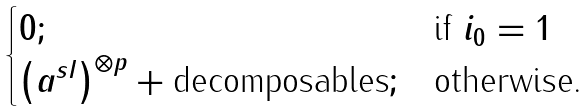Convert formula to latex. <formula><loc_0><loc_0><loc_500><loc_500>\begin{cases} 0 ; & \text {if $i_{0} =1$} \\ \left ( a ^ { s I } \right ) ^ { \otimes p } + \text {decomposables} ; & \text {otherwise.} \end{cases}</formula> 